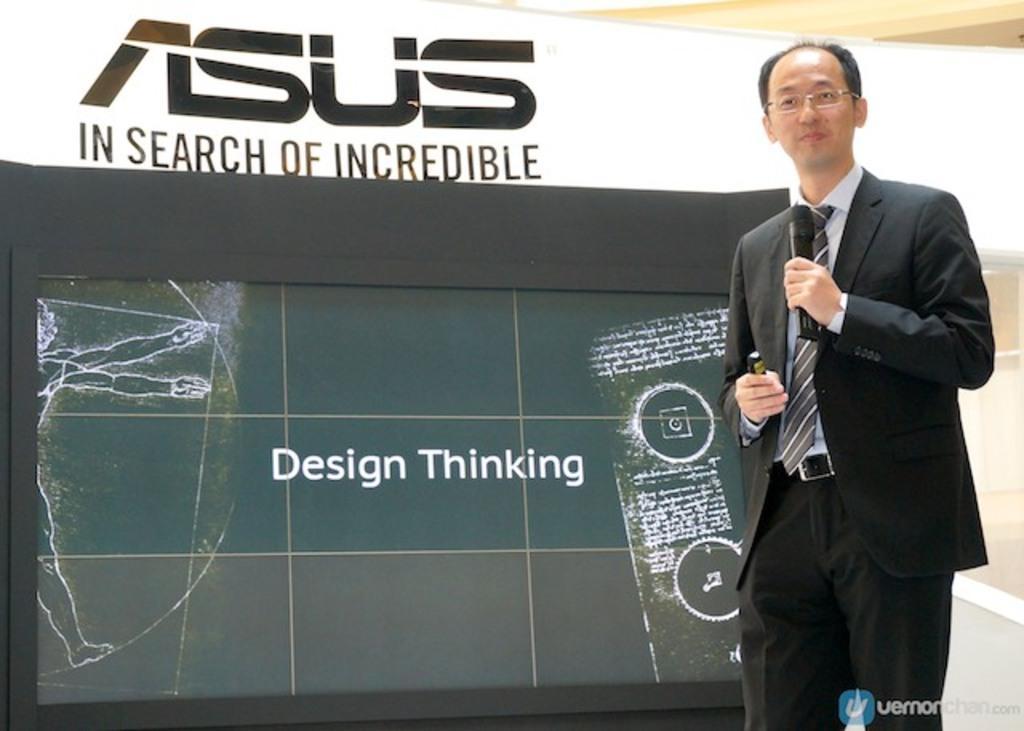Please provide a concise description of this image. In this picture we can see a man holding a mike with his hand and he wore spectacles. In the background we can see a screen and a banner. At the bottom we can see a watermark. 